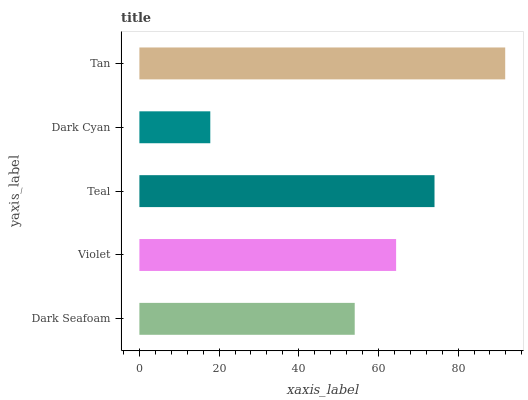Is Dark Cyan the minimum?
Answer yes or no. Yes. Is Tan the maximum?
Answer yes or no. Yes. Is Violet the minimum?
Answer yes or no. No. Is Violet the maximum?
Answer yes or no. No. Is Violet greater than Dark Seafoam?
Answer yes or no. Yes. Is Dark Seafoam less than Violet?
Answer yes or no. Yes. Is Dark Seafoam greater than Violet?
Answer yes or no. No. Is Violet less than Dark Seafoam?
Answer yes or no. No. Is Violet the high median?
Answer yes or no. Yes. Is Violet the low median?
Answer yes or no. Yes. Is Tan the high median?
Answer yes or no. No. Is Teal the low median?
Answer yes or no. No. 